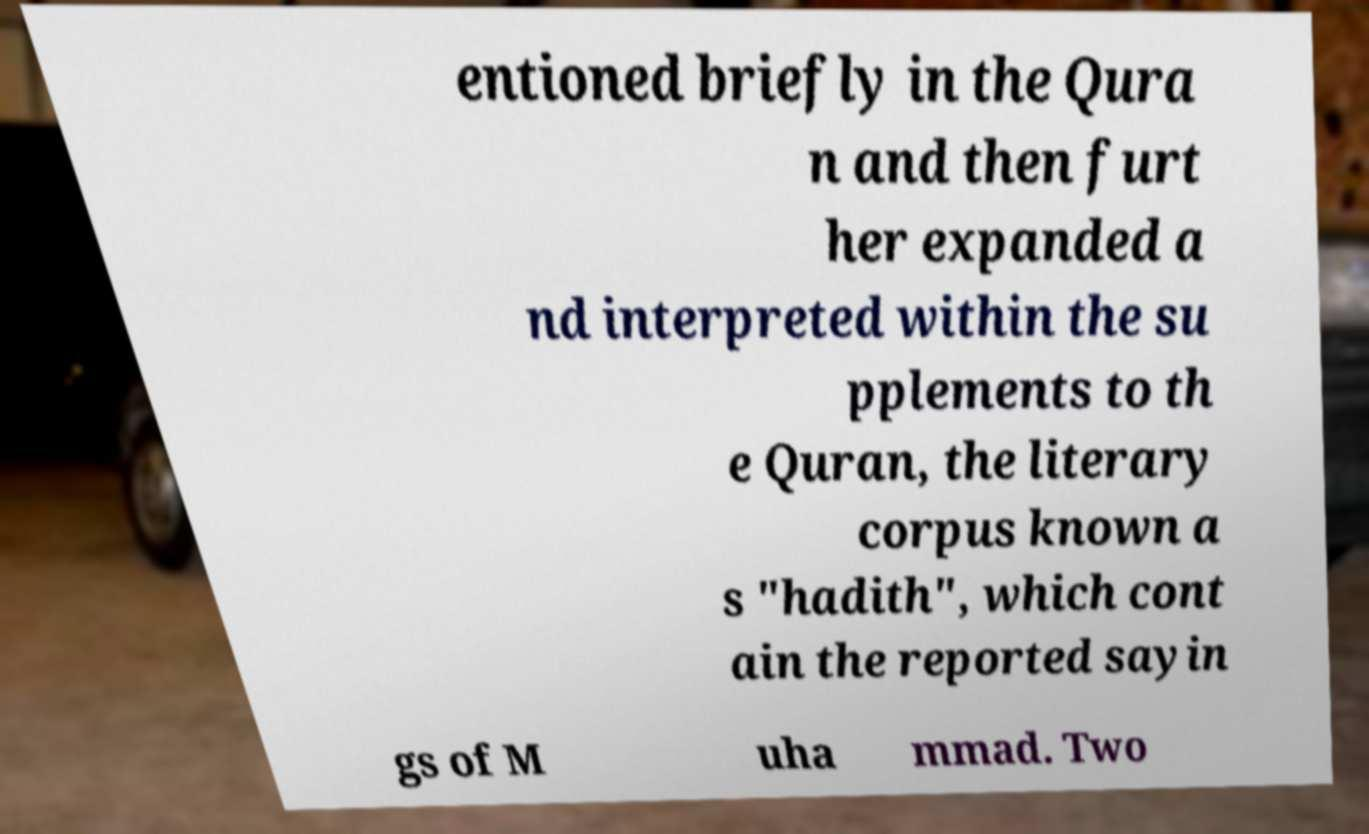Could you extract and type out the text from this image? entioned briefly in the Qura n and then furt her expanded a nd interpreted within the su pplements to th e Quran, the literary corpus known a s "hadith", which cont ain the reported sayin gs of M uha mmad. Two 